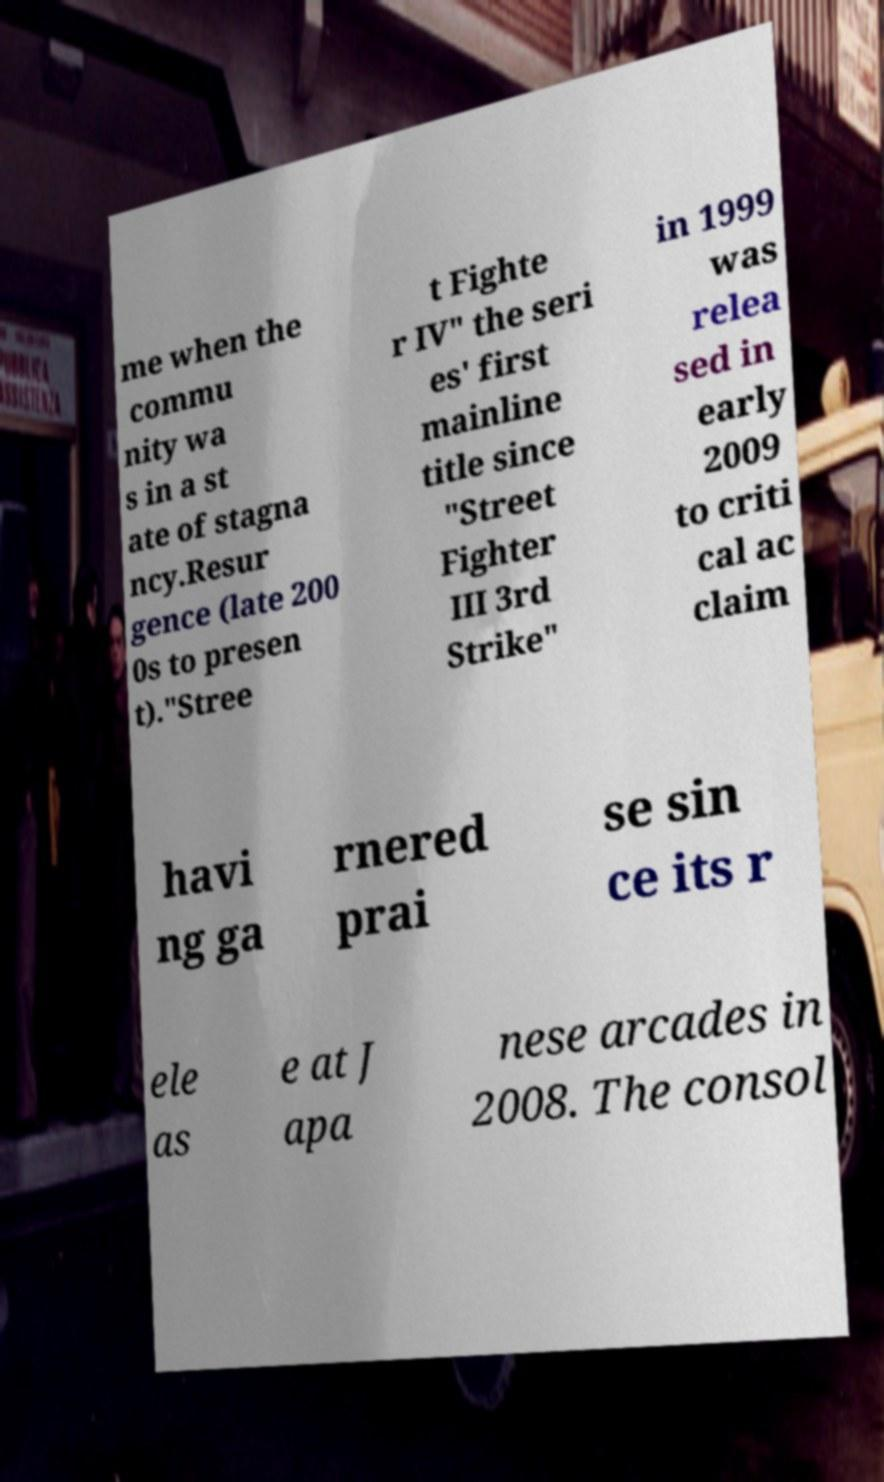Can you accurately transcribe the text from the provided image for me? me when the commu nity wa s in a st ate of stagna ncy.Resur gence (late 200 0s to presen t)."Stree t Fighte r IV" the seri es' first mainline title since "Street Fighter III 3rd Strike" in 1999 was relea sed in early 2009 to criti cal ac claim havi ng ga rnered prai se sin ce its r ele as e at J apa nese arcades in 2008. The consol 